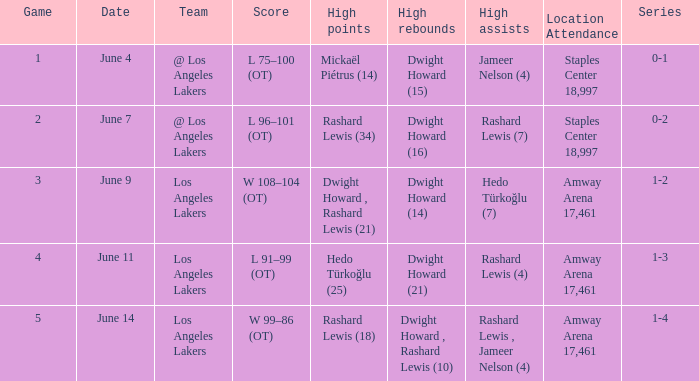What is Series, when Date is "June 7"? 0-2. 